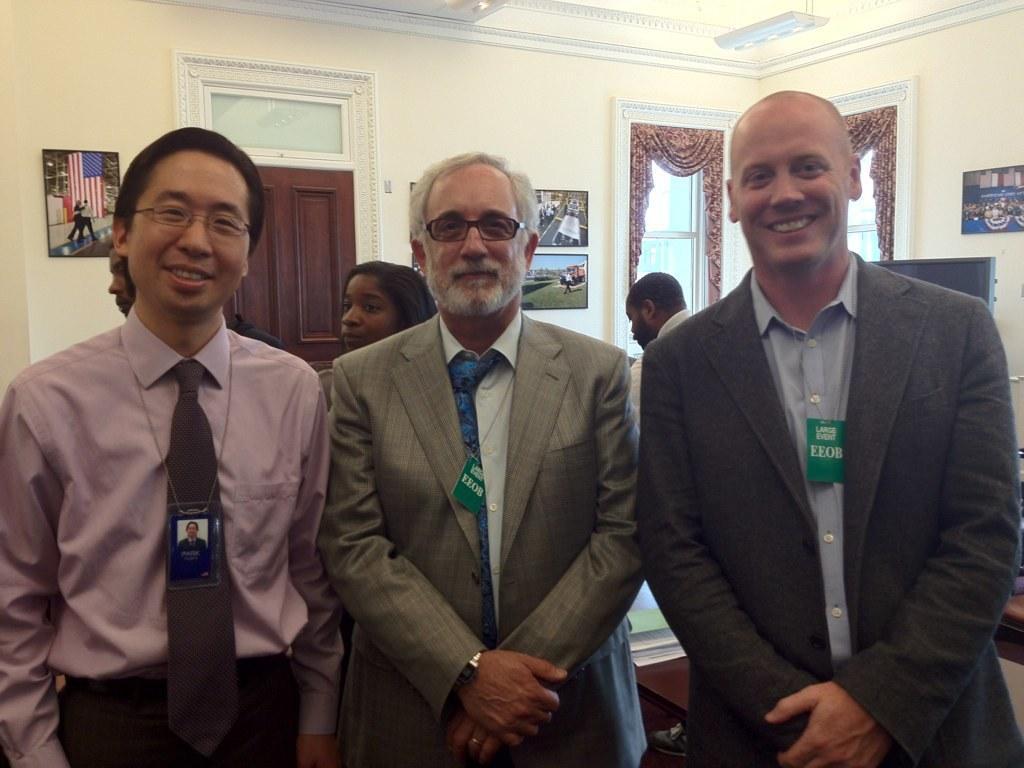Can you describe this image briefly? In this image, there are a few people. We can see the wall with some frames. We can also see a door and some windows, curtains. We can see the roof and a white colored object. 